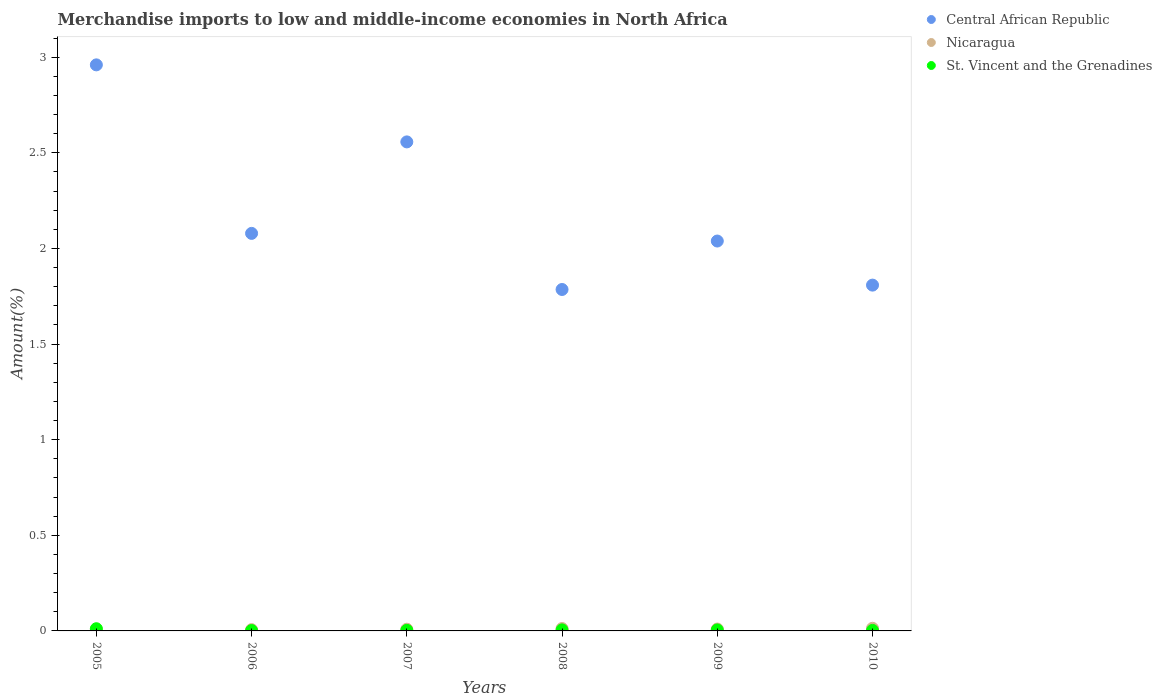How many different coloured dotlines are there?
Provide a succinct answer. 3. What is the percentage of amount earned from merchandise imports in St. Vincent and the Grenadines in 2005?
Make the answer very short. 0.01. Across all years, what is the maximum percentage of amount earned from merchandise imports in Central African Republic?
Provide a short and direct response. 2.96. Across all years, what is the minimum percentage of amount earned from merchandise imports in Central African Republic?
Keep it short and to the point. 1.79. What is the total percentage of amount earned from merchandise imports in St. Vincent and the Grenadines in the graph?
Make the answer very short. 0.03. What is the difference between the percentage of amount earned from merchandise imports in St. Vincent and the Grenadines in 2006 and that in 2009?
Make the answer very short. -0. What is the difference between the percentage of amount earned from merchandise imports in St. Vincent and the Grenadines in 2006 and the percentage of amount earned from merchandise imports in Nicaragua in 2008?
Offer a terse response. -0.01. What is the average percentage of amount earned from merchandise imports in Nicaragua per year?
Make the answer very short. 0.01. In the year 2009, what is the difference between the percentage of amount earned from merchandise imports in St. Vincent and the Grenadines and percentage of amount earned from merchandise imports in Central African Republic?
Offer a terse response. -2.03. In how many years, is the percentage of amount earned from merchandise imports in St. Vincent and the Grenadines greater than 1 %?
Give a very brief answer. 0. What is the ratio of the percentage of amount earned from merchandise imports in Central African Republic in 2007 to that in 2008?
Your response must be concise. 1.43. Is the percentage of amount earned from merchandise imports in Nicaragua in 2007 less than that in 2010?
Make the answer very short. Yes. Is the difference between the percentage of amount earned from merchandise imports in St. Vincent and the Grenadines in 2005 and 2009 greater than the difference between the percentage of amount earned from merchandise imports in Central African Republic in 2005 and 2009?
Provide a short and direct response. No. What is the difference between the highest and the second highest percentage of amount earned from merchandise imports in Nicaragua?
Give a very brief answer. 0. What is the difference between the highest and the lowest percentage of amount earned from merchandise imports in Central African Republic?
Your answer should be very brief. 1.17. In how many years, is the percentage of amount earned from merchandise imports in St. Vincent and the Grenadines greater than the average percentage of amount earned from merchandise imports in St. Vincent and the Grenadines taken over all years?
Ensure brevity in your answer.  3. Is it the case that in every year, the sum of the percentage of amount earned from merchandise imports in Nicaragua and percentage of amount earned from merchandise imports in St. Vincent and the Grenadines  is greater than the percentage of amount earned from merchandise imports in Central African Republic?
Ensure brevity in your answer.  No. How many dotlines are there?
Offer a very short reply. 3. How many years are there in the graph?
Offer a very short reply. 6. What is the difference between two consecutive major ticks on the Y-axis?
Your response must be concise. 0.5. What is the title of the graph?
Provide a succinct answer. Merchandise imports to low and middle-income economies in North Africa. What is the label or title of the Y-axis?
Your answer should be very brief. Amount(%). What is the Amount(%) of Central African Republic in 2005?
Offer a very short reply. 2.96. What is the Amount(%) in Nicaragua in 2005?
Provide a succinct answer. 0.01. What is the Amount(%) of St. Vincent and the Grenadines in 2005?
Make the answer very short. 0.01. What is the Amount(%) in Central African Republic in 2006?
Your response must be concise. 2.08. What is the Amount(%) in Nicaragua in 2006?
Your answer should be compact. 0.01. What is the Amount(%) in St. Vincent and the Grenadines in 2006?
Provide a succinct answer. 0. What is the Amount(%) of Central African Republic in 2007?
Keep it short and to the point. 2.56. What is the Amount(%) in Nicaragua in 2007?
Your answer should be compact. 0.01. What is the Amount(%) of St. Vincent and the Grenadines in 2007?
Provide a succinct answer. 0. What is the Amount(%) in Central African Republic in 2008?
Your answer should be compact. 1.79. What is the Amount(%) of Nicaragua in 2008?
Your answer should be very brief. 0.01. What is the Amount(%) of St. Vincent and the Grenadines in 2008?
Offer a terse response. 0.01. What is the Amount(%) in Central African Republic in 2009?
Provide a short and direct response. 2.04. What is the Amount(%) of Nicaragua in 2009?
Your answer should be very brief. 0.01. What is the Amount(%) of St. Vincent and the Grenadines in 2009?
Ensure brevity in your answer.  0.01. What is the Amount(%) of Central African Republic in 2010?
Provide a short and direct response. 1.81. What is the Amount(%) of Nicaragua in 2010?
Provide a succinct answer. 0.01. What is the Amount(%) of St. Vincent and the Grenadines in 2010?
Give a very brief answer. 0. Across all years, what is the maximum Amount(%) of Central African Republic?
Your answer should be compact. 2.96. Across all years, what is the maximum Amount(%) in Nicaragua?
Your answer should be compact. 0.01. Across all years, what is the maximum Amount(%) of St. Vincent and the Grenadines?
Your answer should be compact. 0.01. Across all years, what is the minimum Amount(%) of Central African Republic?
Your answer should be compact. 1.79. Across all years, what is the minimum Amount(%) of Nicaragua?
Ensure brevity in your answer.  0.01. Across all years, what is the minimum Amount(%) of St. Vincent and the Grenadines?
Ensure brevity in your answer.  0. What is the total Amount(%) of Central African Republic in the graph?
Make the answer very short. 13.23. What is the total Amount(%) of Nicaragua in the graph?
Your answer should be compact. 0.06. What is the total Amount(%) in St. Vincent and the Grenadines in the graph?
Your response must be concise. 0.03. What is the difference between the Amount(%) in Central African Republic in 2005 and that in 2006?
Keep it short and to the point. 0.88. What is the difference between the Amount(%) in Nicaragua in 2005 and that in 2006?
Your answer should be compact. 0. What is the difference between the Amount(%) in St. Vincent and the Grenadines in 2005 and that in 2006?
Your answer should be compact. 0.01. What is the difference between the Amount(%) in Central African Republic in 2005 and that in 2007?
Your response must be concise. 0.4. What is the difference between the Amount(%) of Nicaragua in 2005 and that in 2007?
Provide a succinct answer. -0. What is the difference between the Amount(%) in St. Vincent and the Grenadines in 2005 and that in 2007?
Keep it short and to the point. 0.01. What is the difference between the Amount(%) in Central African Republic in 2005 and that in 2008?
Offer a terse response. 1.17. What is the difference between the Amount(%) in Nicaragua in 2005 and that in 2008?
Your answer should be very brief. -0. What is the difference between the Amount(%) in St. Vincent and the Grenadines in 2005 and that in 2008?
Ensure brevity in your answer.  0.01. What is the difference between the Amount(%) of Central African Republic in 2005 and that in 2009?
Ensure brevity in your answer.  0.92. What is the difference between the Amount(%) in Nicaragua in 2005 and that in 2009?
Offer a terse response. -0. What is the difference between the Amount(%) in St. Vincent and the Grenadines in 2005 and that in 2009?
Keep it short and to the point. 0.01. What is the difference between the Amount(%) of Central African Republic in 2005 and that in 2010?
Your answer should be compact. 1.15. What is the difference between the Amount(%) of Nicaragua in 2005 and that in 2010?
Provide a succinct answer. -0.01. What is the difference between the Amount(%) in St. Vincent and the Grenadines in 2005 and that in 2010?
Your answer should be very brief. 0.01. What is the difference between the Amount(%) in Central African Republic in 2006 and that in 2007?
Offer a terse response. -0.48. What is the difference between the Amount(%) in Nicaragua in 2006 and that in 2007?
Offer a very short reply. -0. What is the difference between the Amount(%) in St. Vincent and the Grenadines in 2006 and that in 2007?
Ensure brevity in your answer.  -0. What is the difference between the Amount(%) in Central African Republic in 2006 and that in 2008?
Ensure brevity in your answer.  0.29. What is the difference between the Amount(%) of Nicaragua in 2006 and that in 2008?
Ensure brevity in your answer.  -0.01. What is the difference between the Amount(%) of St. Vincent and the Grenadines in 2006 and that in 2008?
Your answer should be very brief. -0. What is the difference between the Amount(%) in Central African Republic in 2006 and that in 2009?
Keep it short and to the point. 0.04. What is the difference between the Amount(%) in Nicaragua in 2006 and that in 2009?
Your answer should be very brief. -0. What is the difference between the Amount(%) in St. Vincent and the Grenadines in 2006 and that in 2009?
Your answer should be compact. -0. What is the difference between the Amount(%) of Central African Republic in 2006 and that in 2010?
Ensure brevity in your answer.  0.27. What is the difference between the Amount(%) of Nicaragua in 2006 and that in 2010?
Ensure brevity in your answer.  -0.01. What is the difference between the Amount(%) in St. Vincent and the Grenadines in 2006 and that in 2010?
Provide a succinct answer. -0. What is the difference between the Amount(%) of Central African Republic in 2007 and that in 2008?
Your answer should be very brief. 0.77. What is the difference between the Amount(%) in Nicaragua in 2007 and that in 2008?
Ensure brevity in your answer.  -0. What is the difference between the Amount(%) in St. Vincent and the Grenadines in 2007 and that in 2008?
Make the answer very short. -0. What is the difference between the Amount(%) in Central African Republic in 2007 and that in 2009?
Your response must be concise. 0.52. What is the difference between the Amount(%) in Nicaragua in 2007 and that in 2009?
Make the answer very short. -0. What is the difference between the Amount(%) of St. Vincent and the Grenadines in 2007 and that in 2009?
Provide a short and direct response. -0. What is the difference between the Amount(%) of Central African Republic in 2007 and that in 2010?
Provide a succinct answer. 0.75. What is the difference between the Amount(%) of Nicaragua in 2007 and that in 2010?
Provide a short and direct response. -0. What is the difference between the Amount(%) in St. Vincent and the Grenadines in 2007 and that in 2010?
Make the answer very short. 0. What is the difference between the Amount(%) of Central African Republic in 2008 and that in 2009?
Give a very brief answer. -0.25. What is the difference between the Amount(%) of Nicaragua in 2008 and that in 2009?
Ensure brevity in your answer.  0. What is the difference between the Amount(%) in St. Vincent and the Grenadines in 2008 and that in 2009?
Your response must be concise. 0. What is the difference between the Amount(%) in Central African Republic in 2008 and that in 2010?
Offer a very short reply. -0.02. What is the difference between the Amount(%) in Nicaragua in 2008 and that in 2010?
Provide a succinct answer. -0. What is the difference between the Amount(%) of St. Vincent and the Grenadines in 2008 and that in 2010?
Your answer should be very brief. 0. What is the difference between the Amount(%) of Central African Republic in 2009 and that in 2010?
Your response must be concise. 0.23. What is the difference between the Amount(%) of Nicaragua in 2009 and that in 2010?
Offer a terse response. -0. What is the difference between the Amount(%) in St. Vincent and the Grenadines in 2009 and that in 2010?
Keep it short and to the point. 0. What is the difference between the Amount(%) of Central African Republic in 2005 and the Amount(%) of Nicaragua in 2006?
Your response must be concise. 2.95. What is the difference between the Amount(%) in Central African Republic in 2005 and the Amount(%) in St. Vincent and the Grenadines in 2006?
Keep it short and to the point. 2.96. What is the difference between the Amount(%) in Nicaragua in 2005 and the Amount(%) in St. Vincent and the Grenadines in 2006?
Your answer should be very brief. 0.01. What is the difference between the Amount(%) in Central African Republic in 2005 and the Amount(%) in Nicaragua in 2007?
Offer a very short reply. 2.95. What is the difference between the Amount(%) in Central African Republic in 2005 and the Amount(%) in St. Vincent and the Grenadines in 2007?
Provide a succinct answer. 2.96. What is the difference between the Amount(%) of Nicaragua in 2005 and the Amount(%) of St. Vincent and the Grenadines in 2007?
Make the answer very short. 0. What is the difference between the Amount(%) in Central African Republic in 2005 and the Amount(%) in Nicaragua in 2008?
Your answer should be compact. 2.95. What is the difference between the Amount(%) of Central African Republic in 2005 and the Amount(%) of St. Vincent and the Grenadines in 2008?
Offer a very short reply. 2.95. What is the difference between the Amount(%) of Nicaragua in 2005 and the Amount(%) of St. Vincent and the Grenadines in 2008?
Your answer should be compact. 0. What is the difference between the Amount(%) in Central African Republic in 2005 and the Amount(%) in Nicaragua in 2009?
Offer a terse response. 2.95. What is the difference between the Amount(%) of Central African Republic in 2005 and the Amount(%) of St. Vincent and the Grenadines in 2009?
Your answer should be compact. 2.95. What is the difference between the Amount(%) in Nicaragua in 2005 and the Amount(%) in St. Vincent and the Grenadines in 2009?
Ensure brevity in your answer.  0. What is the difference between the Amount(%) of Central African Republic in 2005 and the Amount(%) of Nicaragua in 2010?
Your response must be concise. 2.95. What is the difference between the Amount(%) in Central African Republic in 2005 and the Amount(%) in St. Vincent and the Grenadines in 2010?
Offer a terse response. 2.96. What is the difference between the Amount(%) in Nicaragua in 2005 and the Amount(%) in St. Vincent and the Grenadines in 2010?
Your answer should be compact. 0.01. What is the difference between the Amount(%) in Central African Republic in 2006 and the Amount(%) in Nicaragua in 2007?
Your answer should be compact. 2.07. What is the difference between the Amount(%) of Central African Republic in 2006 and the Amount(%) of St. Vincent and the Grenadines in 2007?
Make the answer very short. 2.08. What is the difference between the Amount(%) in Nicaragua in 2006 and the Amount(%) in St. Vincent and the Grenadines in 2007?
Make the answer very short. 0. What is the difference between the Amount(%) of Central African Republic in 2006 and the Amount(%) of Nicaragua in 2008?
Provide a succinct answer. 2.07. What is the difference between the Amount(%) in Central African Republic in 2006 and the Amount(%) in St. Vincent and the Grenadines in 2008?
Make the answer very short. 2.07. What is the difference between the Amount(%) of Nicaragua in 2006 and the Amount(%) of St. Vincent and the Grenadines in 2008?
Offer a very short reply. 0. What is the difference between the Amount(%) of Central African Republic in 2006 and the Amount(%) of Nicaragua in 2009?
Your response must be concise. 2.07. What is the difference between the Amount(%) of Central African Republic in 2006 and the Amount(%) of St. Vincent and the Grenadines in 2009?
Keep it short and to the point. 2.07. What is the difference between the Amount(%) of Nicaragua in 2006 and the Amount(%) of St. Vincent and the Grenadines in 2009?
Keep it short and to the point. 0. What is the difference between the Amount(%) of Central African Republic in 2006 and the Amount(%) of Nicaragua in 2010?
Offer a very short reply. 2.06. What is the difference between the Amount(%) in Central African Republic in 2006 and the Amount(%) in St. Vincent and the Grenadines in 2010?
Offer a very short reply. 2.08. What is the difference between the Amount(%) of Nicaragua in 2006 and the Amount(%) of St. Vincent and the Grenadines in 2010?
Offer a very short reply. 0. What is the difference between the Amount(%) of Central African Republic in 2007 and the Amount(%) of Nicaragua in 2008?
Your answer should be very brief. 2.54. What is the difference between the Amount(%) in Central African Republic in 2007 and the Amount(%) in St. Vincent and the Grenadines in 2008?
Your response must be concise. 2.55. What is the difference between the Amount(%) of Nicaragua in 2007 and the Amount(%) of St. Vincent and the Grenadines in 2008?
Your answer should be very brief. 0. What is the difference between the Amount(%) of Central African Republic in 2007 and the Amount(%) of Nicaragua in 2009?
Your response must be concise. 2.55. What is the difference between the Amount(%) in Central African Republic in 2007 and the Amount(%) in St. Vincent and the Grenadines in 2009?
Offer a terse response. 2.55. What is the difference between the Amount(%) in Nicaragua in 2007 and the Amount(%) in St. Vincent and the Grenadines in 2009?
Your answer should be compact. 0. What is the difference between the Amount(%) of Central African Republic in 2007 and the Amount(%) of Nicaragua in 2010?
Give a very brief answer. 2.54. What is the difference between the Amount(%) of Central African Republic in 2007 and the Amount(%) of St. Vincent and the Grenadines in 2010?
Provide a succinct answer. 2.55. What is the difference between the Amount(%) of Nicaragua in 2007 and the Amount(%) of St. Vincent and the Grenadines in 2010?
Provide a succinct answer. 0.01. What is the difference between the Amount(%) in Central African Republic in 2008 and the Amount(%) in Nicaragua in 2009?
Provide a succinct answer. 1.78. What is the difference between the Amount(%) in Central African Republic in 2008 and the Amount(%) in St. Vincent and the Grenadines in 2009?
Ensure brevity in your answer.  1.78. What is the difference between the Amount(%) of Nicaragua in 2008 and the Amount(%) of St. Vincent and the Grenadines in 2009?
Provide a short and direct response. 0.01. What is the difference between the Amount(%) of Central African Republic in 2008 and the Amount(%) of Nicaragua in 2010?
Ensure brevity in your answer.  1.77. What is the difference between the Amount(%) in Central African Republic in 2008 and the Amount(%) in St. Vincent and the Grenadines in 2010?
Your answer should be very brief. 1.78. What is the difference between the Amount(%) in Nicaragua in 2008 and the Amount(%) in St. Vincent and the Grenadines in 2010?
Make the answer very short. 0.01. What is the difference between the Amount(%) of Central African Republic in 2009 and the Amount(%) of Nicaragua in 2010?
Provide a short and direct response. 2.02. What is the difference between the Amount(%) of Central African Republic in 2009 and the Amount(%) of St. Vincent and the Grenadines in 2010?
Make the answer very short. 2.04. What is the difference between the Amount(%) of Nicaragua in 2009 and the Amount(%) of St. Vincent and the Grenadines in 2010?
Make the answer very short. 0.01. What is the average Amount(%) in Central African Republic per year?
Provide a short and direct response. 2.2. What is the average Amount(%) of Nicaragua per year?
Keep it short and to the point. 0.01. What is the average Amount(%) in St. Vincent and the Grenadines per year?
Your answer should be very brief. 0.01. In the year 2005, what is the difference between the Amount(%) of Central African Republic and Amount(%) of Nicaragua?
Provide a succinct answer. 2.95. In the year 2005, what is the difference between the Amount(%) of Central African Republic and Amount(%) of St. Vincent and the Grenadines?
Provide a short and direct response. 2.95. In the year 2005, what is the difference between the Amount(%) in Nicaragua and Amount(%) in St. Vincent and the Grenadines?
Keep it short and to the point. -0. In the year 2006, what is the difference between the Amount(%) of Central African Republic and Amount(%) of Nicaragua?
Make the answer very short. 2.07. In the year 2006, what is the difference between the Amount(%) of Central African Republic and Amount(%) of St. Vincent and the Grenadines?
Offer a very short reply. 2.08. In the year 2006, what is the difference between the Amount(%) of Nicaragua and Amount(%) of St. Vincent and the Grenadines?
Keep it short and to the point. 0. In the year 2007, what is the difference between the Amount(%) of Central African Republic and Amount(%) of Nicaragua?
Offer a very short reply. 2.55. In the year 2007, what is the difference between the Amount(%) in Central African Republic and Amount(%) in St. Vincent and the Grenadines?
Your answer should be very brief. 2.55. In the year 2007, what is the difference between the Amount(%) of Nicaragua and Amount(%) of St. Vincent and the Grenadines?
Ensure brevity in your answer.  0.01. In the year 2008, what is the difference between the Amount(%) in Central African Republic and Amount(%) in Nicaragua?
Ensure brevity in your answer.  1.77. In the year 2008, what is the difference between the Amount(%) of Central African Republic and Amount(%) of St. Vincent and the Grenadines?
Offer a terse response. 1.78. In the year 2008, what is the difference between the Amount(%) of Nicaragua and Amount(%) of St. Vincent and the Grenadines?
Keep it short and to the point. 0.01. In the year 2009, what is the difference between the Amount(%) of Central African Republic and Amount(%) of Nicaragua?
Offer a very short reply. 2.03. In the year 2009, what is the difference between the Amount(%) in Central African Republic and Amount(%) in St. Vincent and the Grenadines?
Make the answer very short. 2.03. In the year 2009, what is the difference between the Amount(%) of Nicaragua and Amount(%) of St. Vincent and the Grenadines?
Provide a short and direct response. 0. In the year 2010, what is the difference between the Amount(%) in Central African Republic and Amount(%) in Nicaragua?
Provide a short and direct response. 1.79. In the year 2010, what is the difference between the Amount(%) of Central African Republic and Amount(%) of St. Vincent and the Grenadines?
Offer a very short reply. 1.81. In the year 2010, what is the difference between the Amount(%) in Nicaragua and Amount(%) in St. Vincent and the Grenadines?
Your answer should be very brief. 0.01. What is the ratio of the Amount(%) of Central African Republic in 2005 to that in 2006?
Keep it short and to the point. 1.42. What is the ratio of the Amount(%) of Nicaragua in 2005 to that in 2006?
Keep it short and to the point. 1.17. What is the ratio of the Amount(%) in St. Vincent and the Grenadines in 2005 to that in 2006?
Your answer should be very brief. 5.92. What is the ratio of the Amount(%) of Central African Republic in 2005 to that in 2007?
Give a very brief answer. 1.16. What is the ratio of the Amount(%) of Nicaragua in 2005 to that in 2007?
Offer a very short reply. 0.89. What is the ratio of the Amount(%) of St. Vincent and the Grenadines in 2005 to that in 2007?
Give a very brief answer. 3.73. What is the ratio of the Amount(%) of Central African Republic in 2005 to that in 2008?
Offer a very short reply. 1.66. What is the ratio of the Amount(%) of Nicaragua in 2005 to that in 2008?
Offer a terse response. 0.64. What is the ratio of the Amount(%) in St. Vincent and the Grenadines in 2005 to that in 2008?
Your response must be concise. 2.11. What is the ratio of the Amount(%) of Central African Republic in 2005 to that in 2009?
Give a very brief answer. 1.45. What is the ratio of the Amount(%) of Nicaragua in 2005 to that in 2009?
Keep it short and to the point. 0.8. What is the ratio of the Amount(%) in St. Vincent and the Grenadines in 2005 to that in 2009?
Keep it short and to the point. 2.2. What is the ratio of the Amount(%) in Central African Republic in 2005 to that in 2010?
Offer a very short reply. 1.64. What is the ratio of the Amount(%) of Nicaragua in 2005 to that in 2010?
Provide a succinct answer. 0.58. What is the ratio of the Amount(%) in St. Vincent and the Grenadines in 2005 to that in 2010?
Give a very brief answer. 4.35. What is the ratio of the Amount(%) of Central African Republic in 2006 to that in 2007?
Provide a succinct answer. 0.81. What is the ratio of the Amount(%) of Nicaragua in 2006 to that in 2007?
Your answer should be very brief. 0.76. What is the ratio of the Amount(%) of St. Vincent and the Grenadines in 2006 to that in 2007?
Provide a succinct answer. 0.63. What is the ratio of the Amount(%) of Central African Republic in 2006 to that in 2008?
Give a very brief answer. 1.16. What is the ratio of the Amount(%) in Nicaragua in 2006 to that in 2008?
Offer a very short reply. 0.54. What is the ratio of the Amount(%) in St. Vincent and the Grenadines in 2006 to that in 2008?
Make the answer very short. 0.36. What is the ratio of the Amount(%) in Central African Republic in 2006 to that in 2009?
Offer a very short reply. 1.02. What is the ratio of the Amount(%) of Nicaragua in 2006 to that in 2009?
Offer a very short reply. 0.68. What is the ratio of the Amount(%) in St. Vincent and the Grenadines in 2006 to that in 2009?
Offer a terse response. 0.37. What is the ratio of the Amount(%) in Central African Republic in 2006 to that in 2010?
Your response must be concise. 1.15. What is the ratio of the Amount(%) of Nicaragua in 2006 to that in 2010?
Make the answer very short. 0.49. What is the ratio of the Amount(%) of St. Vincent and the Grenadines in 2006 to that in 2010?
Provide a short and direct response. 0.73. What is the ratio of the Amount(%) of Central African Republic in 2007 to that in 2008?
Provide a succinct answer. 1.43. What is the ratio of the Amount(%) in Nicaragua in 2007 to that in 2008?
Give a very brief answer. 0.72. What is the ratio of the Amount(%) in St. Vincent and the Grenadines in 2007 to that in 2008?
Offer a terse response. 0.57. What is the ratio of the Amount(%) of Central African Republic in 2007 to that in 2009?
Provide a succinct answer. 1.25. What is the ratio of the Amount(%) in Nicaragua in 2007 to that in 2009?
Your response must be concise. 0.9. What is the ratio of the Amount(%) in St. Vincent and the Grenadines in 2007 to that in 2009?
Give a very brief answer. 0.59. What is the ratio of the Amount(%) in Central African Republic in 2007 to that in 2010?
Provide a short and direct response. 1.41. What is the ratio of the Amount(%) in Nicaragua in 2007 to that in 2010?
Your answer should be very brief. 0.65. What is the ratio of the Amount(%) of St. Vincent and the Grenadines in 2007 to that in 2010?
Your answer should be compact. 1.16. What is the ratio of the Amount(%) of Central African Republic in 2008 to that in 2009?
Give a very brief answer. 0.88. What is the ratio of the Amount(%) in Nicaragua in 2008 to that in 2009?
Make the answer very short. 1.26. What is the ratio of the Amount(%) in St. Vincent and the Grenadines in 2008 to that in 2009?
Give a very brief answer. 1.04. What is the ratio of the Amount(%) in Central African Republic in 2008 to that in 2010?
Your response must be concise. 0.99. What is the ratio of the Amount(%) of Nicaragua in 2008 to that in 2010?
Provide a short and direct response. 0.91. What is the ratio of the Amount(%) in St. Vincent and the Grenadines in 2008 to that in 2010?
Ensure brevity in your answer.  2.06. What is the ratio of the Amount(%) in Central African Republic in 2009 to that in 2010?
Ensure brevity in your answer.  1.13. What is the ratio of the Amount(%) in Nicaragua in 2009 to that in 2010?
Give a very brief answer. 0.72. What is the ratio of the Amount(%) of St. Vincent and the Grenadines in 2009 to that in 2010?
Provide a succinct answer. 1.98. What is the difference between the highest and the second highest Amount(%) in Central African Republic?
Keep it short and to the point. 0.4. What is the difference between the highest and the second highest Amount(%) of Nicaragua?
Give a very brief answer. 0. What is the difference between the highest and the second highest Amount(%) in St. Vincent and the Grenadines?
Offer a very short reply. 0.01. What is the difference between the highest and the lowest Amount(%) in Central African Republic?
Keep it short and to the point. 1.17. What is the difference between the highest and the lowest Amount(%) in Nicaragua?
Give a very brief answer. 0.01. What is the difference between the highest and the lowest Amount(%) in St. Vincent and the Grenadines?
Ensure brevity in your answer.  0.01. 